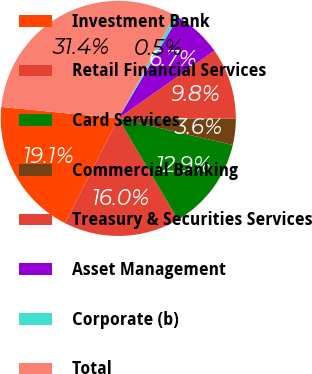Convert chart. <chart><loc_0><loc_0><loc_500><loc_500><pie_chart><fcel>Investment Bank<fcel>Retail Financial Services<fcel>Card Services<fcel>Commercial Banking<fcel>Treasury & Securities Services<fcel>Asset Management<fcel>Corporate (b)<fcel>Total<nl><fcel>19.06%<fcel>15.98%<fcel>12.89%<fcel>3.62%<fcel>9.8%<fcel>6.71%<fcel>0.53%<fcel>31.42%<nl></chart> 